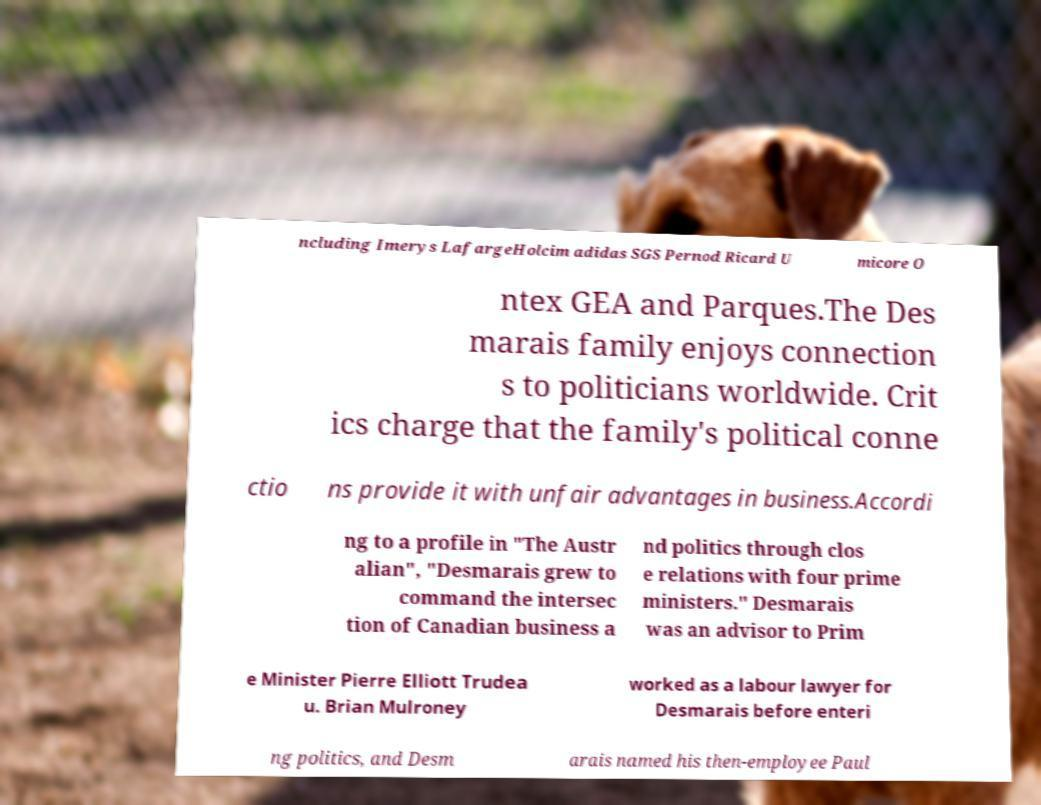Could you extract and type out the text from this image? ncluding Imerys LafargeHolcim adidas SGS Pernod Ricard U micore O ntex GEA and Parques.The Des marais family enjoys connection s to politicians worldwide. Crit ics charge that the family's political conne ctio ns provide it with unfair advantages in business.Accordi ng to a profile in "The Austr alian", "Desmarais grew to command the intersec tion of Canadian business a nd politics through clos e relations with four prime ministers." Desmarais was an advisor to Prim e Minister Pierre Elliott Trudea u. Brian Mulroney worked as a labour lawyer for Desmarais before enteri ng politics, and Desm arais named his then-employee Paul 